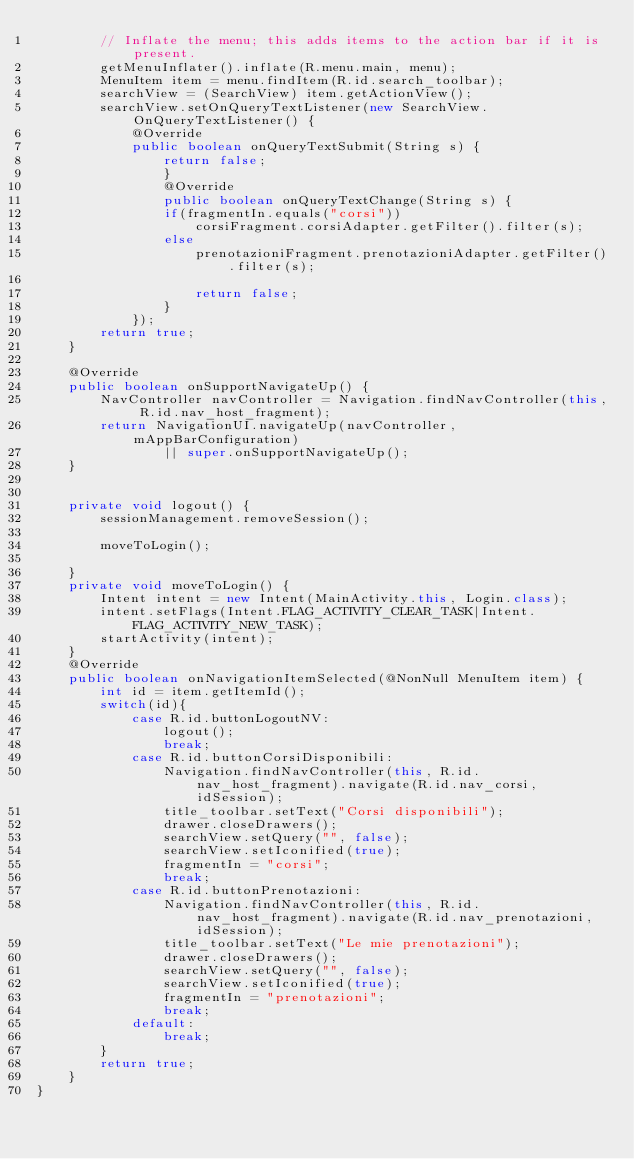Convert code to text. <code><loc_0><loc_0><loc_500><loc_500><_Java_>        // Inflate the menu; this adds items to the action bar if it is present.
        getMenuInflater().inflate(R.menu.main, menu);
        MenuItem item = menu.findItem(R.id.search_toolbar);
        searchView = (SearchView) item.getActionView();
        searchView.setOnQueryTextListener(new SearchView.OnQueryTextListener() {
            @Override
            public boolean onQueryTextSubmit(String s) {
                return false;
                }
                @Override
                public boolean onQueryTextChange(String s) {
                if(fragmentIn.equals("corsi"))
                    corsiFragment.corsiAdapter.getFilter().filter(s);
                else
                    prenotazioniFragment.prenotazioniAdapter.getFilter().filter(s);

                    return false;
                }
            });
        return true;
    }

    @Override
    public boolean onSupportNavigateUp() {
        NavController navController = Navigation.findNavController(this, R.id.nav_host_fragment);
        return NavigationUI.navigateUp(navController, mAppBarConfiguration)
                || super.onSupportNavigateUp();
    }


    private void logout() {
        sessionManagement.removeSession();

        moveToLogin();

    }
    private void moveToLogin() {
        Intent intent = new Intent(MainActivity.this, Login.class);
        intent.setFlags(Intent.FLAG_ACTIVITY_CLEAR_TASK|Intent.FLAG_ACTIVITY_NEW_TASK);
        startActivity(intent);
    }
    @Override
    public boolean onNavigationItemSelected(@NonNull MenuItem item) {
        int id = item.getItemId();
        switch(id){
            case R.id.buttonLogoutNV:
                logout();
                break;
            case R.id.buttonCorsiDisponibili:
                Navigation.findNavController(this, R.id.nav_host_fragment).navigate(R.id.nav_corsi, idSession);
                title_toolbar.setText("Corsi disponibili");
                drawer.closeDrawers();
                searchView.setQuery("", false);
                searchView.setIconified(true);
                fragmentIn = "corsi";
                break;
            case R.id.buttonPrenotazioni:
                Navigation.findNavController(this, R.id.nav_host_fragment).navigate(R.id.nav_prenotazioni, idSession);
                title_toolbar.setText("Le mie prenotazioni");
                drawer.closeDrawers();
                searchView.setQuery("", false);
                searchView.setIconified(true);
                fragmentIn = "prenotazioni";
                break;
            default:
                break;
        }
        return true;
    }
}</code> 